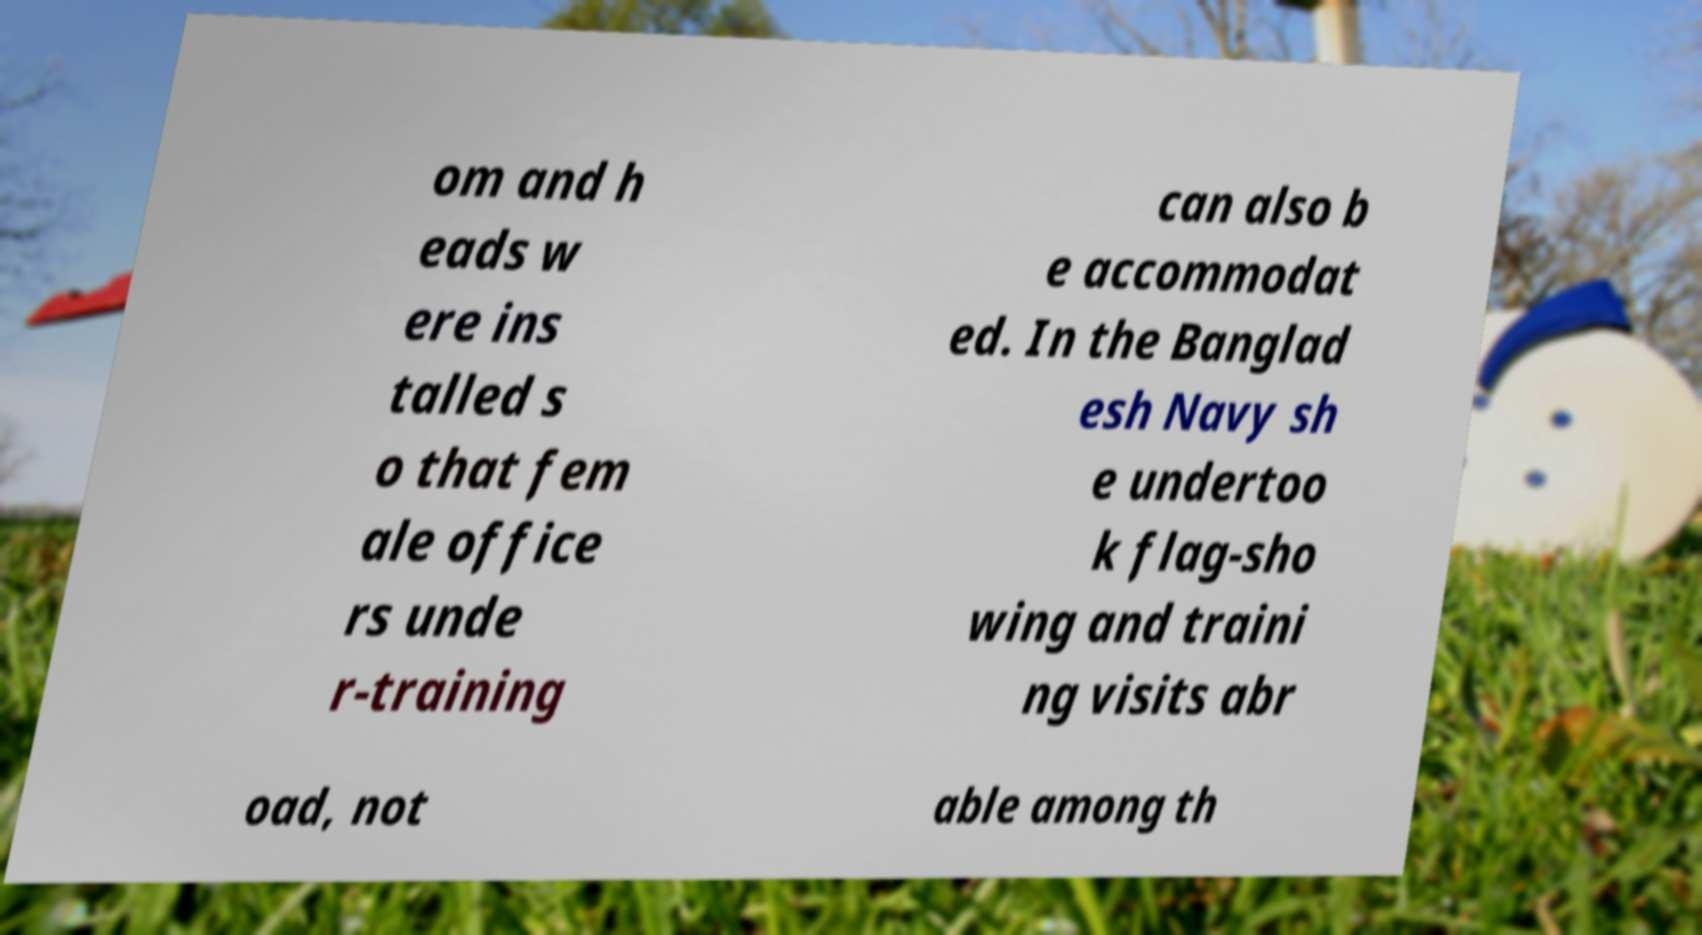Could you extract and type out the text from this image? om and h eads w ere ins talled s o that fem ale office rs unde r-training can also b e accommodat ed. In the Banglad esh Navy sh e undertoo k flag-sho wing and traini ng visits abr oad, not able among th 